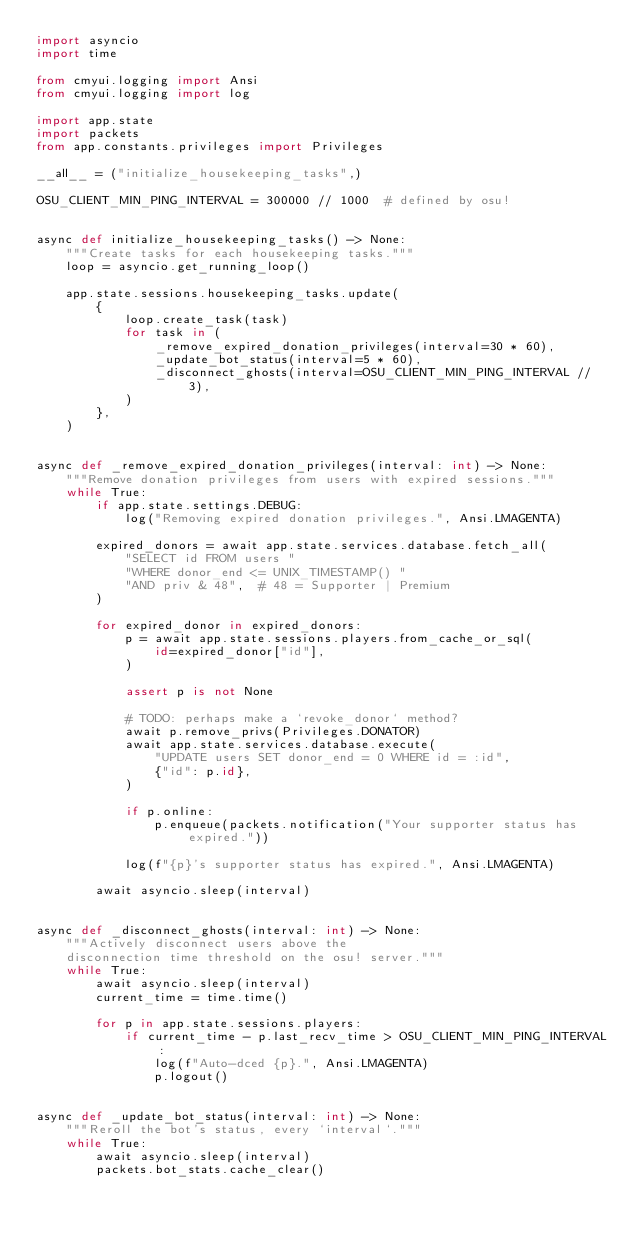Convert code to text. <code><loc_0><loc_0><loc_500><loc_500><_Python_>import asyncio
import time

from cmyui.logging import Ansi
from cmyui.logging import log

import app.state
import packets
from app.constants.privileges import Privileges

__all__ = ("initialize_housekeeping_tasks",)

OSU_CLIENT_MIN_PING_INTERVAL = 300000 // 1000  # defined by osu!


async def initialize_housekeeping_tasks() -> None:
    """Create tasks for each housekeeping tasks."""
    loop = asyncio.get_running_loop()

    app.state.sessions.housekeeping_tasks.update(
        {
            loop.create_task(task)
            for task in (
                _remove_expired_donation_privileges(interval=30 * 60),
                _update_bot_status(interval=5 * 60),
                _disconnect_ghosts(interval=OSU_CLIENT_MIN_PING_INTERVAL // 3),
            )
        },
    )


async def _remove_expired_donation_privileges(interval: int) -> None:
    """Remove donation privileges from users with expired sessions."""
    while True:
        if app.state.settings.DEBUG:
            log("Removing expired donation privileges.", Ansi.LMAGENTA)

        expired_donors = await app.state.services.database.fetch_all(
            "SELECT id FROM users "
            "WHERE donor_end <= UNIX_TIMESTAMP() "
            "AND priv & 48",  # 48 = Supporter | Premium
        )

        for expired_donor in expired_donors:
            p = await app.state.sessions.players.from_cache_or_sql(
                id=expired_donor["id"],
            )

            assert p is not None

            # TODO: perhaps make a `revoke_donor` method?
            await p.remove_privs(Privileges.DONATOR)
            await app.state.services.database.execute(
                "UPDATE users SET donor_end = 0 WHERE id = :id",
                {"id": p.id},
            )

            if p.online:
                p.enqueue(packets.notification("Your supporter status has expired."))

            log(f"{p}'s supporter status has expired.", Ansi.LMAGENTA)

        await asyncio.sleep(interval)


async def _disconnect_ghosts(interval: int) -> None:
    """Actively disconnect users above the
    disconnection time threshold on the osu! server."""
    while True:
        await asyncio.sleep(interval)
        current_time = time.time()

        for p in app.state.sessions.players:
            if current_time - p.last_recv_time > OSU_CLIENT_MIN_PING_INTERVAL:
                log(f"Auto-dced {p}.", Ansi.LMAGENTA)
                p.logout()


async def _update_bot_status(interval: int) -> None:
    """Reroll the bot's status, every `interval`."""
    while True:
        await asyncio.sleep(interval)
        packets.bot_stats.cache_clear()
</code> 